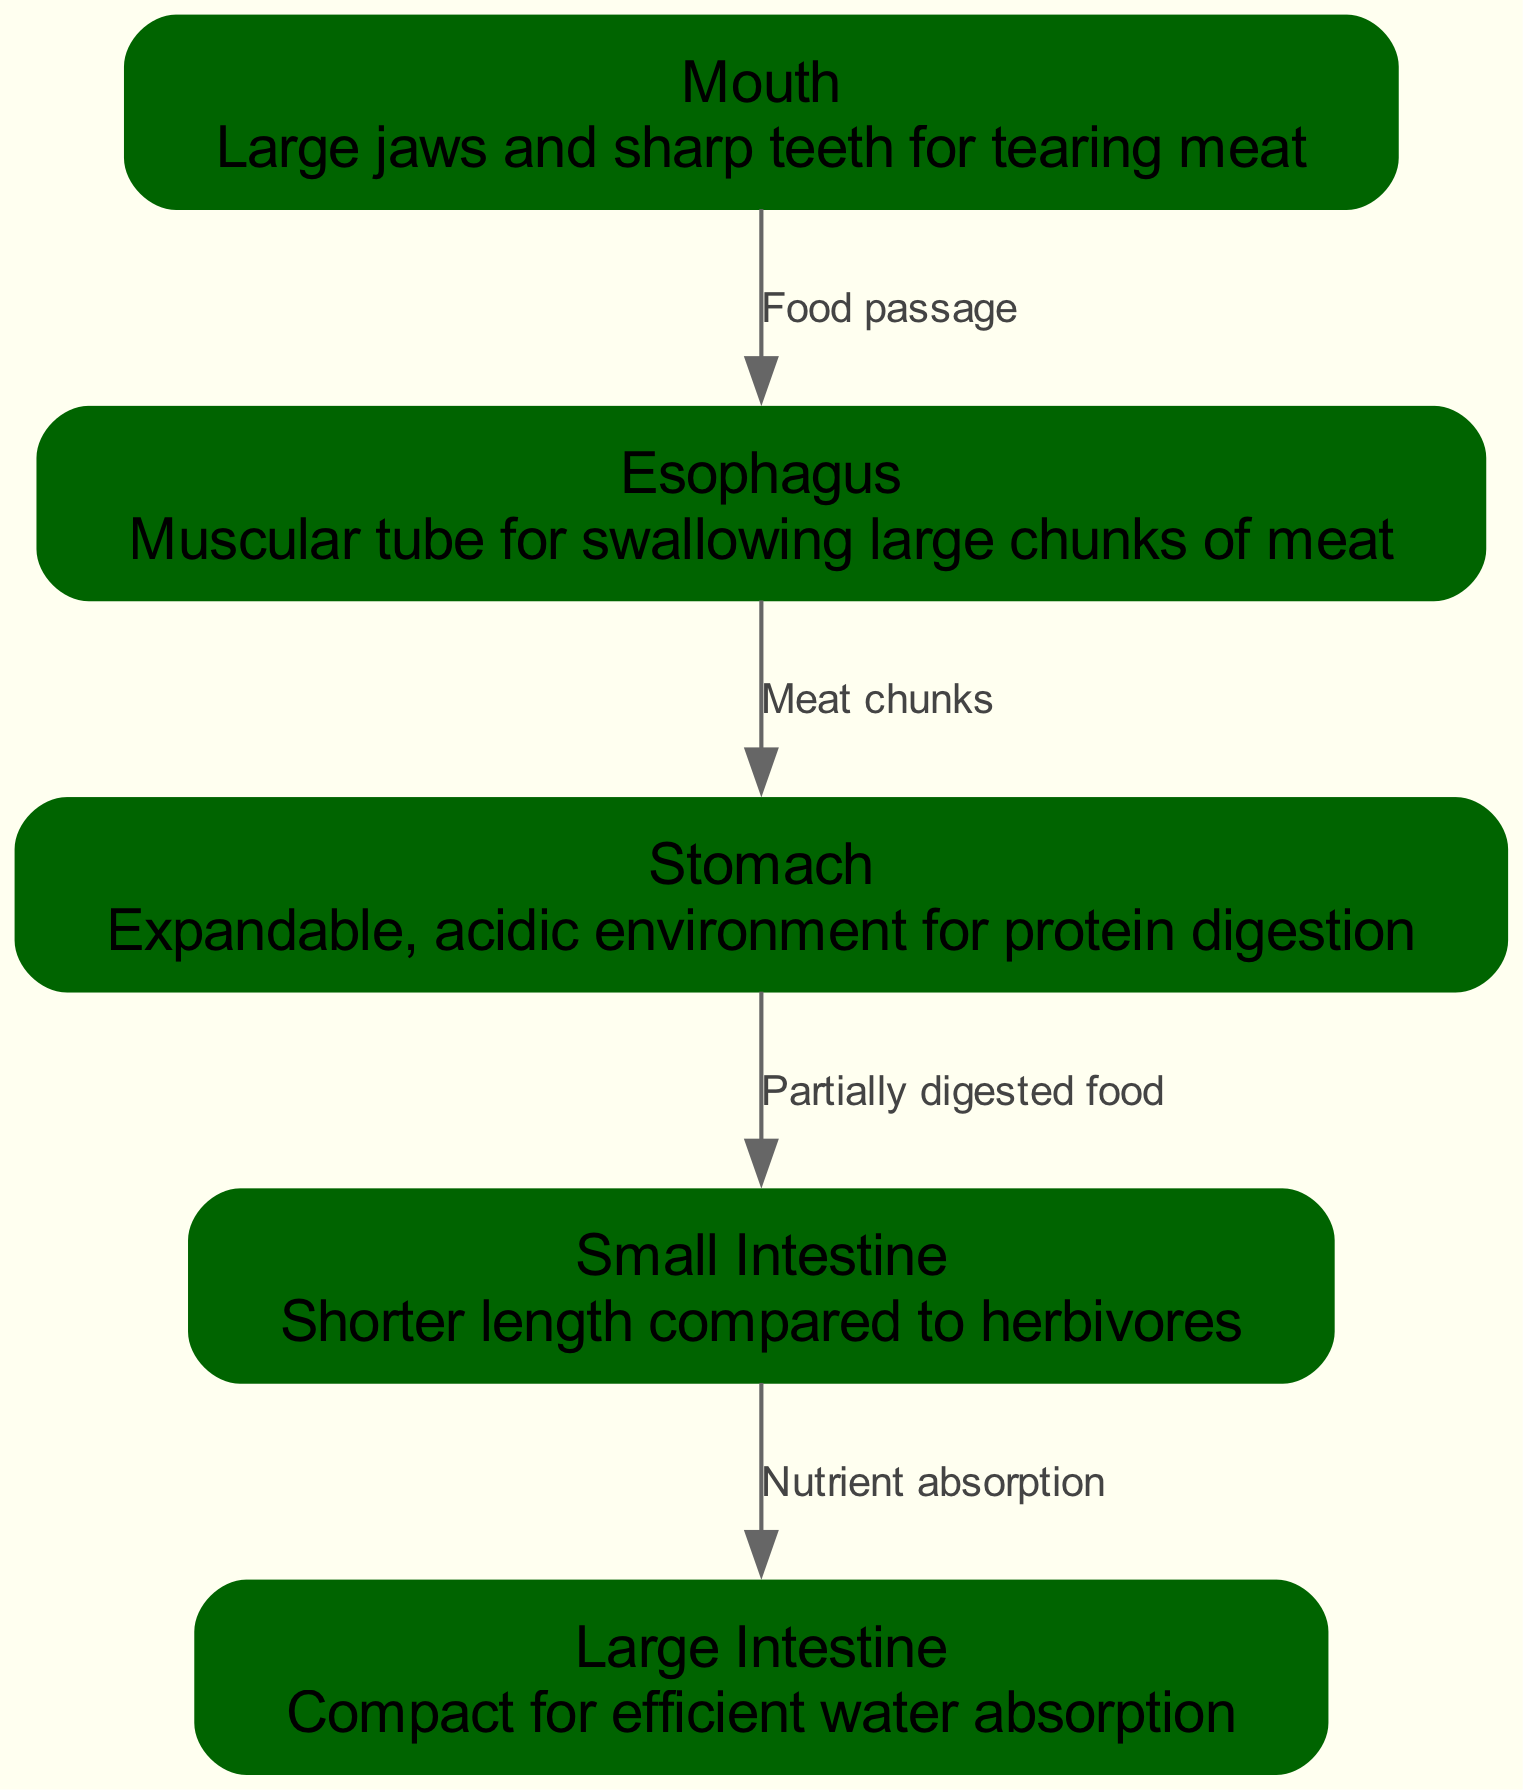What is the main function of the mouth in the lion's digestive system? The mouth has large jaws and sharp teeth that are specifically adapted for tearing meat, which is crucial for a carnivorous diet.
Answer: Large jaws and sharp teeth for tearing meat What does the esophagus connect? The esophagus connects the mouth to the stomach as it serves as a passage for swallowed food.
Answer: Mouth to stomach How many nodes are present in the diagram? The diagram contains a total of five nodes representing different parts of the lion's digestive system: mouth, esophagus, stomach, small intestine, and large intestine.
Answer: Five What type of environment does the stomach provide? The stomach provides an expandable, acidic environment that is suitable for protein digestion, which is essential for carnivores like lions.
Answer: Expandable, acidic environment What is the primary role of the small intestine in this system? The primary role of the small intestine is nutrient absorption, which occurs after partially digested food passes from the stomach.
Answer: Nutrient absorption How does the size of the small intestine compare to that of herbivores? Compared to herbivores, the small intestine of a lion is shorter, which is an adaptation to its carnivorous diet.
Answer: Shorter length What happens to partially digested food after it leaves the stomach? After leaving the stomach, the partially digested food moves into the small intestine where further digestion and nutrient absorption takes place.
Answer: Moves into the small intestine How is the large intestine adapted for lions? The large intestine is compact to allow for efficient water absorption, which is important given the dietary habits of lions.
Answer: Compact for efficient water absorption What is the relationship between the small intestine and the large intestine? The small intestine is responsible for nutrient absorption, and it connects to the large intestine where further processing of waste occurs after nutrients are extracted.
Answer: Nutrient absorption 